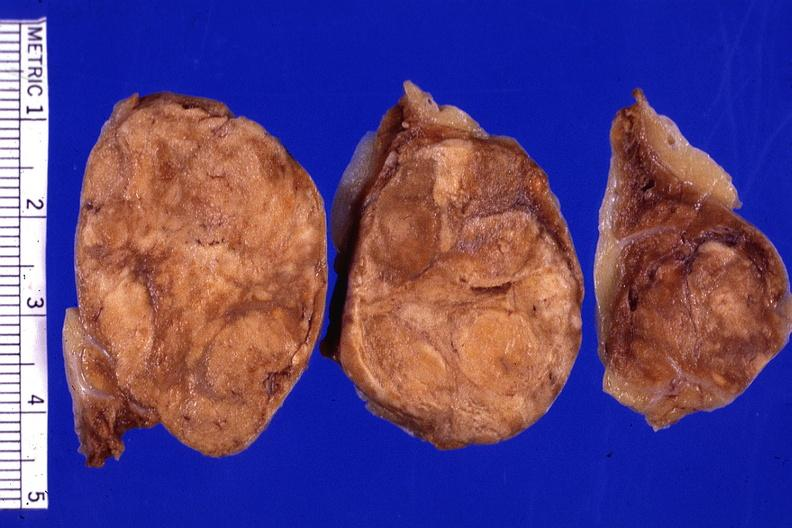what is present?
Answer the question using a single word or phrase. Adenoma 